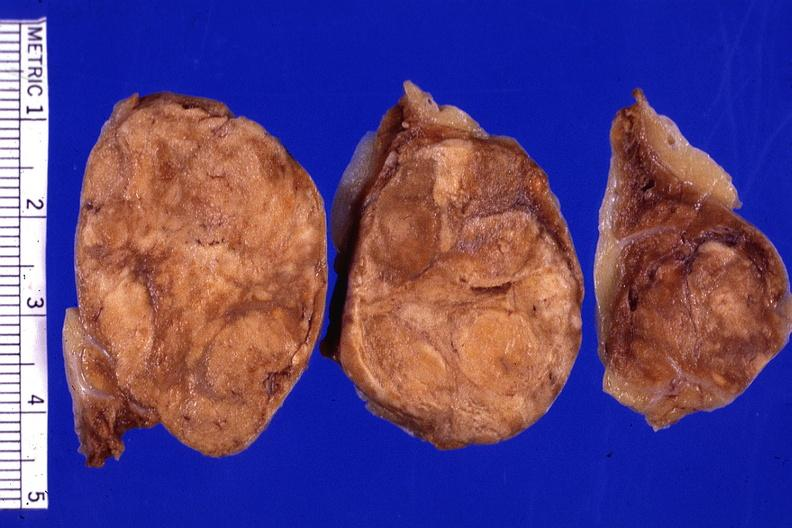what is present?
Answer the question using a single word or phrase. Adenoma 